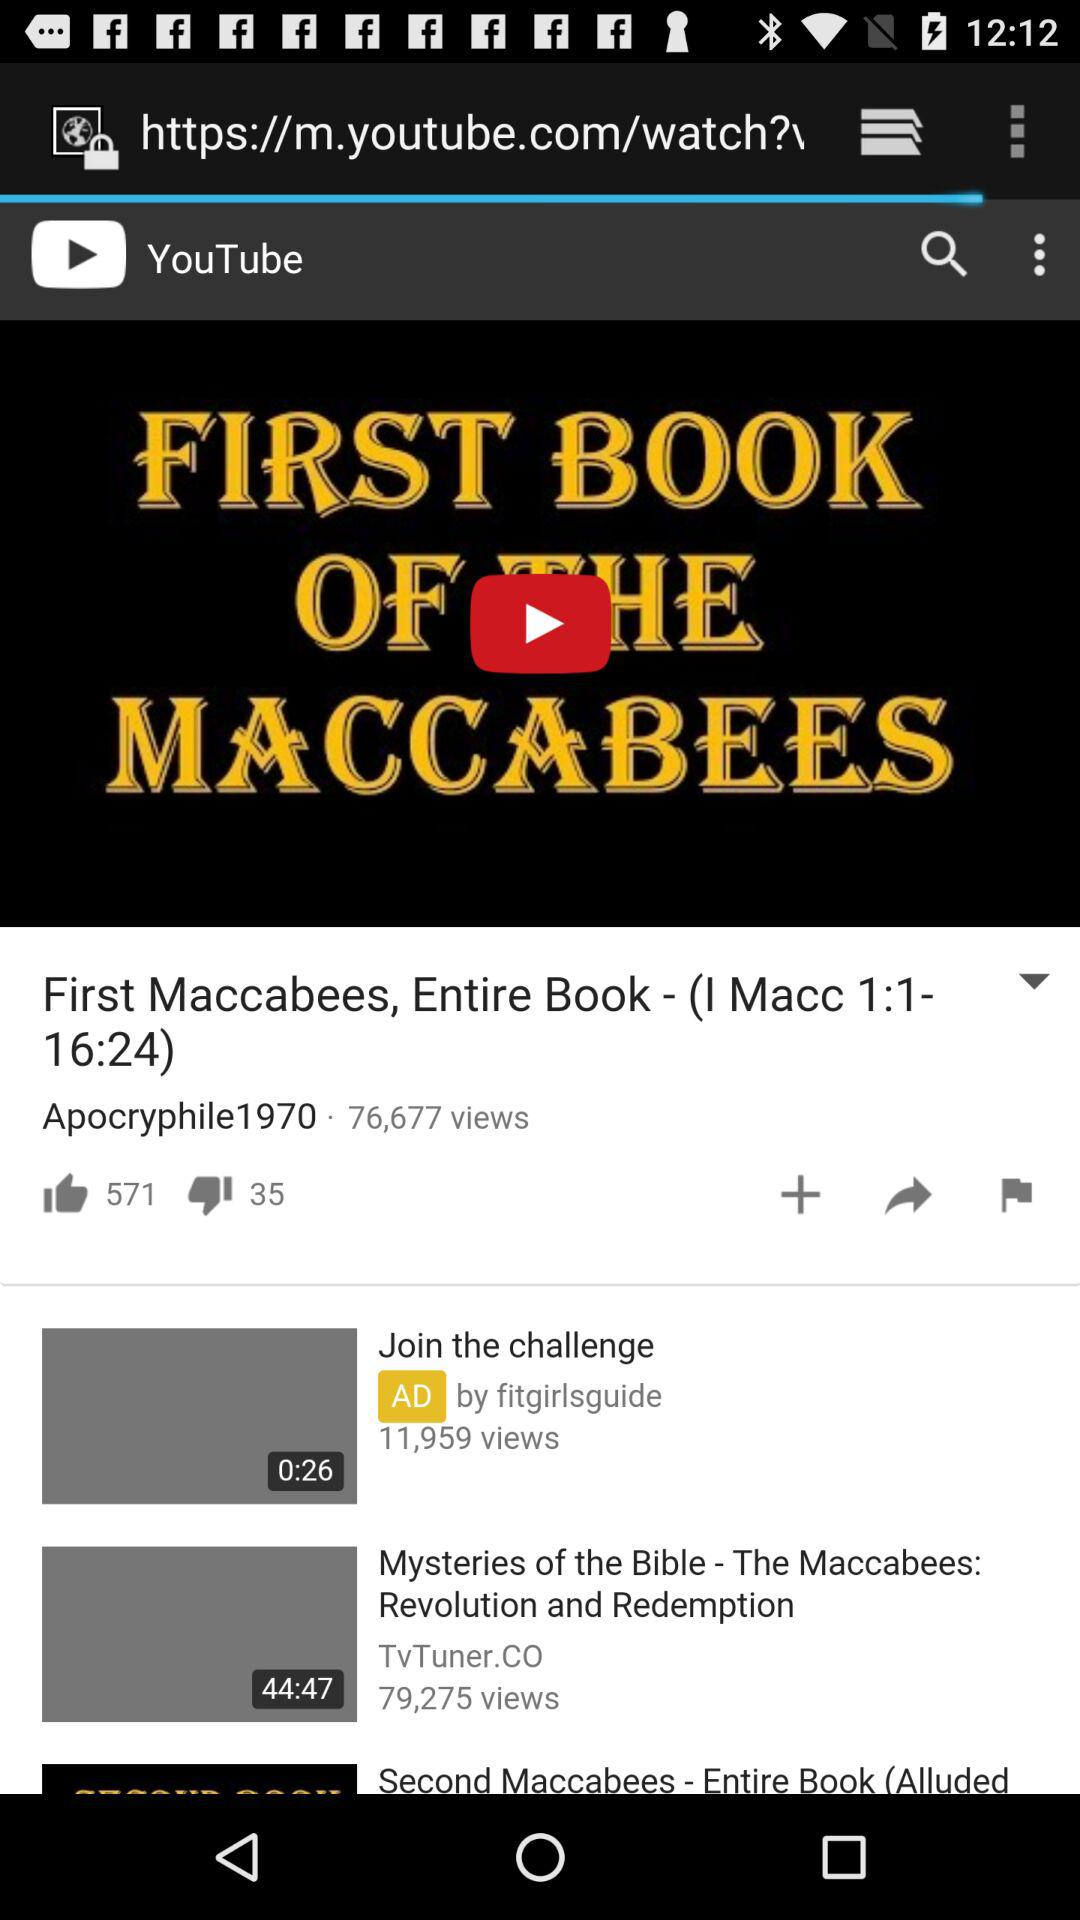What is the number of likes of the video? The number of likes is 571. 